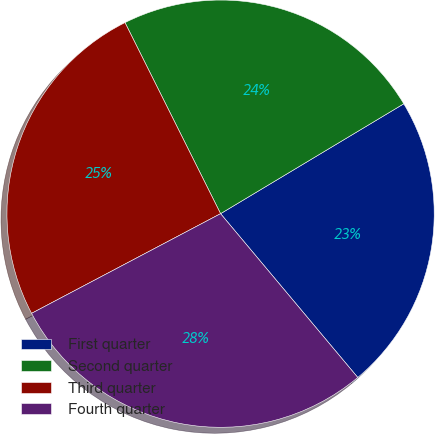<chart> <loc_0><loc_0><loc_500><loc_500><pie_chart><fcel>First quarter<fcel>Second quarter<fcel>Third quarter<fcel>Fourth quarter<nl><fcel>22.5%<fcel>23.78%<fcel>25.34%<fcel>28.37%<nl></chart> 